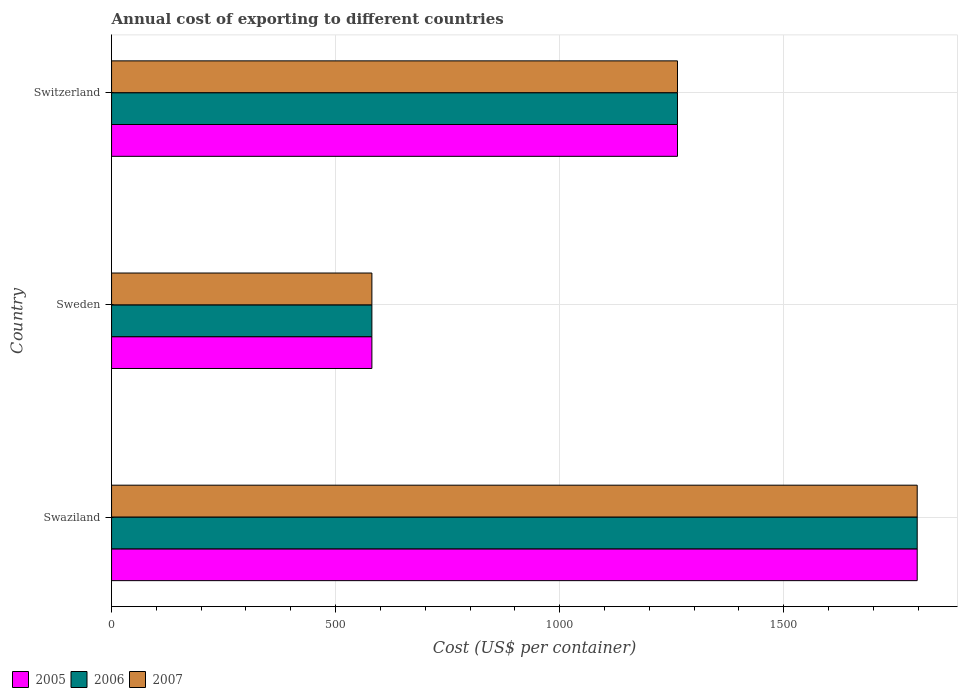Are the number of bars on each tick of the Y-axis equal?
Make the answer very short. Yes. How many bars are there on the 2nd tick from the top?
Your answer should be very brief. 3. How many bars are there on the 3rd tick from the bottom?
Give a very brief answer. 3. What is the label of the 3rd group of bars from the top?
Your answer should be very brief. Swaziland. What is the total annual cost of exporting in 2007 in Sweden?
Give a very brief answer. 581. Across all countries, what is the maximum total annual cost of exporting in 2007?
Provide a short and direct response. 1798. Across all countries, what is the minimum total annual cost of exporting in 2006?
Provide a succinct answer. 581. In which country was the total annual cost of exporting in 2005 maximum?
Make the answer very short. Swaziland. In which country was the total annual cost of exporting in 2007 minimum?
Provide a short and direct response. Sweden. What is the total total annual cost of exporting in 2006 in the graph?
Ensure brevity in your answer.  3642. What is the difference between the total annual cost of exporting in 2006 in Swaziland and that in Sweden?
Your answer should be very brief. 1217. What is the difference between the total annual cost of exporting in 2006 in Switzerland and the total annual cost of exporting in 2007 in Swaziland?
Provide a short and direct response. -535. What is the average total annual cost of exporting in 2005 per country?
Ensure brevity in your answer.  1214. What is the difference between the total annual cost of exporting in 2005 and total annual cost of exporting in 2007 in Swaziland?
Give a very brief answer. 0. In how many countries, is the total annual cost of exporting in 2006 greater than 1700 US$?
Ensure brevity in your answer.  1. What is the ratio of the total annual cost of exporting in 2005 in Swaziland to that in Sweden?
Give a very brief answer. 3.09. Is the total annual cost of exporting in 2005 in Swaziland less than that in Switzerland?
Give a very brief answer. No. What is the difference between the highest and the second highest total annual cost of exporting in 2005?
Provide a short and direct response. 535. What is the difference between the highest and the lowest total annual cost of exporting in 2006?
Keep it short and to the point. 1217. What does the 3rd bar from the bottom in Sweden represents?
Make the answer very short. 2007. Is it the case that in every country, the sum of the total annual cost of exporting in 2005 and total annual cost of exporting in 2006 is greater than the total annual cost of exporting in 2007?
Offer a terse response. Yes. How many bars are there?
Ensure brevity in your answer.  9. Are all the bars in the graph horizontal?
Your response must be concise. Yes. Are the values on the major ticks of X-axis written in scientific E-notation?
Offer a very short reply. No. Does the graph contain any zero values?
Your response must be concise. No. Does the graph contain grids?
Make the answer very short. Yes. Where does the legend appear in the graph?
Give a very brief answer. Bottom left. How are the legend labels stacked?
Ensure brevity in your answer.  Horizontal. What is the title of the graph?
Make the answer very short. Annual cost of exporting to different countries. What is the label or title of the X-axis?
Ensure brevity in your answer.  Cost (US$ per container). What is the Cost (US$ per container) in 2005 in Swaziland?
Keep it short and to the point. 1798. What is the Cost (US$ per container) in 2006 in Swaziland?
Provide a succinct answer. 1798. What is the Cost (US$ per container) in 2007 in Swaziland?
Your answer should be compact. 1798. What is the Cost (US$ per container) in 2005 in Sweden?
Offer a very short reply. 581. What is the Cost (US$ per container) of 2006 in Sweden?
Keep it short and to the point. 581. What is the Cost (US$ per container) of 2007 in Sweden?
Provide a short and direct response. 581. What is the Cost (US$ per container) of 2005 in Switzerland?
Offer a terse response. 1263. What is the Cost (US$ per container) in 2006 in Switzerland?
Offer a very short reply. 1263. What is the Cost (US$ per container) in 2007 in Switzerland?
Ensure brevity in your answer.  1263. Across all countries, what is the maximum Cost (US$ per container) of 2005?
Your answer should be very brief. 1798. Across all countries, what is the maximum Cost (US$ per container) in 2006?
Your answer should be compact. 1798. Across all countries, what is the maximum Cost (US$ per container) in 2007?
Provide a succinct answer. 1798. Across all countries, what is the minimum Cost (US$ per container) in 2005?
Your answer should be compact. 581. Across all countries, what is the minimum Cost (US$ per container) in 2006?
Provide a succinct answer. 581. Across all countries, what is the minimum Cost (US$ per container) in 2007?
Offer a very short reply. 581. What is the total Cost (US$ per container) in 2005 in the graph?
Your answer should be very brief. 3642. What is the total Cost (US$ per container) of 2006 in the graph?
Make the answer very short. 3642. What is the total Cost (US$ per container) in 2007 in the graph?
Offer a very short reply. 3642. What is the difference between the Cost (US$ per container) of 2005 in Swaziland and that in Sweden?
Make the answer very short. 1217. What is the difference between the Cost (US$ per container) of 2006 in Swaziland and that in Sweden?
Your answer should be compact. 1217. What is the difference between the Cost (US$ per container) in 2007 in Swaziland and that in Sweden?
Give a very brief answer. 1217. What is the difference between the Cost (US$ per container) in 2005 in Swaziland and that in Switzerland?
Your answer should be compact. 535. What is the difference between the Cost (US$ per container) of 2006 in Swaziland and that in Switzerland?
Keep it short and to the point. 535. What is the difference between the Cost (US$ per container) in 2007 in Swaziland and that in Switzerland?
Make the answer very short. 535. What is the difference between the Cost (US$ per container) in 2005 in Sweden and that in Switzerland?
Ensure brevity in your answer.  -682. What is the difference between the Cost (US$ per container) of 2006 in Sweden and that in Switzerland?
Give a very brief answer. -682. What is the difference between the Cost (US$ per container) in 2007 in Sweden and that in Switzerland?
Your answer should be very brief. -682. What is the difference between the Cost (US$ per container) of 2005 in Swaziland and the Cost (US$ per container) of 2006 in Sweden?
Your answer should be compact. 1217. What is the difference between the Cost (US$ per container) of 2005 in Swaziland and the Cost (US$ per container) of 2007 in Sweden?
Provide a short and direct response. 1217. What is the difference between the Cost (US$ per container) of 2006 in Swaziland and the Cost (US$ per container) of 2007 in Sweden?
Provide a short and direct response. 1217. What is the difference between the Cost (US$ per container) of 2005 in Swaziland and the Cost (US$ per container) of 2006 in Switzerland?
Your response must be concise. 535. What is the difference between the Cost (US$ per container) in 2005 in Swaziland and the Cost (US$ per container) in 2007 in Switzerland?
Make the answer very short. 535. What is the difference between the Cost (US$ per container) of 2006 in Swaziland and the Cost (US$ per container) of 2007 in Switzerland?
Your response must be concise. 535. What is the difference between the Cost (US$ per container) in 2005 in Sweden and the Cost (US$ per container) in 2006 in Switzerland?
Your answer should be very brief. -682. What is the difference between the Cost (US$ per container) in 2005 in Sweden and the Cost (US$ per container) in 2007 in Switzerland?
Make the answer very short. -682. What is the difference between the Cost (US$ per container) of 2006 in Sweden and the Cost (US$ per container) of 2007 in Switzerland?
Your response must be concise. -682. What is the average Cost (US$ per container) in 2005 per country?
Keep it short and to the point. 1214. What is the average Cost (US$ per container) in 2006 per country?
Keep it short and to the point. 1214. What is the average Cost (US$ per container) in 2007 per country?
Give a very brief answer. 1214. What is the difference between the Cost (US$ per container) in 2005 and Cost (US$ per container) in 2006 in Swaziland?
Ensure brevity in your answer.  0. What is the difference between the Cost (US$ per container) in 2005 and Cost (US$ per container) in 2007 in Swaziland?
Give a very brief answer. 0. What is the difference between the Cost (US$ per container) of 2005 and Cost (US$ per container) of 2006 in Sweden?
Give a very brief answer. 0. What is the ratio of the Cost (US$ per container) of 2005 in Swaziland to that in Sweden?
Keep it short and to the point. 3.09. What is the ratio of the Cost (US$ per container) of 2006 in Swaziland to that in Sweden?
Provide a succinct answer. 3.09. What is the ratio of the Cost (US$ per container) in 2007 in Swaziland to that in Sweden?
Offer a terse response. 3.09. What is the ratio of the Cost (US$ per container) in 2005 in Swaziland to that in Switzerland?
Offer a terse response. 1.42. What is the ratio of the Cost (US$ per container) in 2006 in Swaziland to that in Switzerland?
Keep it short and to the point. 1.42. What is the ratio of the Cost (US$ per container) in 2007 in Swaziland to that in Switzerland?
Keep it short and to the point. 1.42. What is the ratio of the Cost (US$ per container) of 2005 in Sweden to that in Switzerland?
Provide a succinct answer. 0.46. What is the ratio of the Cost (US$ per container) of 2006 in Sweden to that in Switzerland?
Offer a terse response. 0.46. What is the ratio of the Cost (US$ per container) of 2007 in Sweden to that in Switzerland?
Make the answer very short. 0.46. What is the difference between the highest and the second highest Cost (US$ per container) in 2005?
Your answer should be compact. 535. What is the difference between the highest and the second highest Cost (US$ per container) in 2006?
Make the answer very short. 535. What is the difference between the highest and the second highest Cost (US$ per container) of 2007?
Make the answer very short. 535. What is the difference between the highest and the lowest Cost (US$ per container) in 2005?
Your response must be concise. 1217. What is the difference between the highest and the lowest Cost (US$ per container) in 2006?
Offer a very short reply. 1217. What is the difference between the highest and the lowest Cost (US$ per container) in 2007?
Give a very brief answer. 1217. 